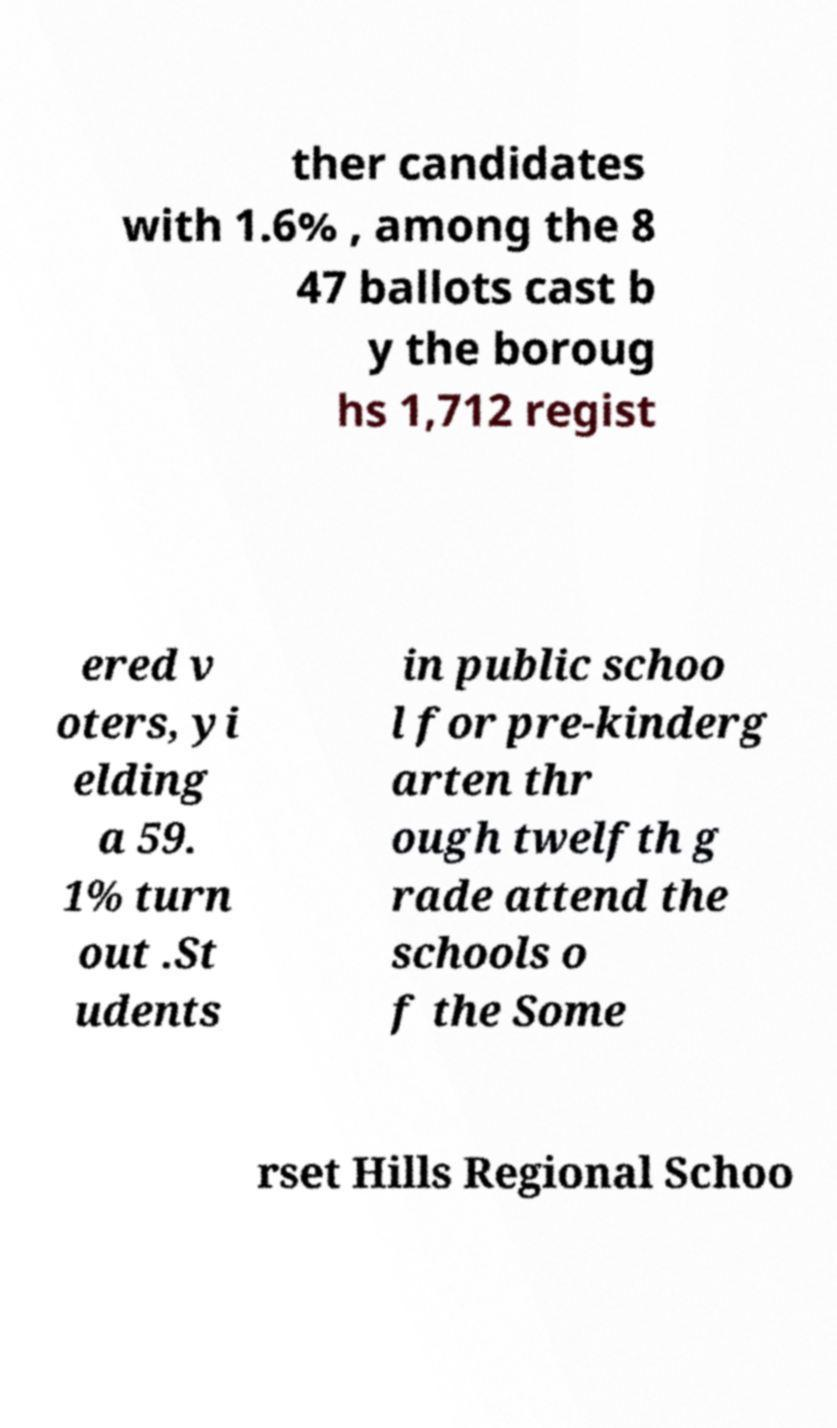For documentation purposes, I need the text within this image transcribed. Could you provide that? ther candidates with 1.6% , among the 8 47 ballots cast b y the boroug hs 1,712 regist ered v oters, yi elding a 59. 1% turn out .St udents in public schoo l for pre-kinderg arten thr ough twelfth g rade attend the schools o f the Some rset Hills Regional Schoo 